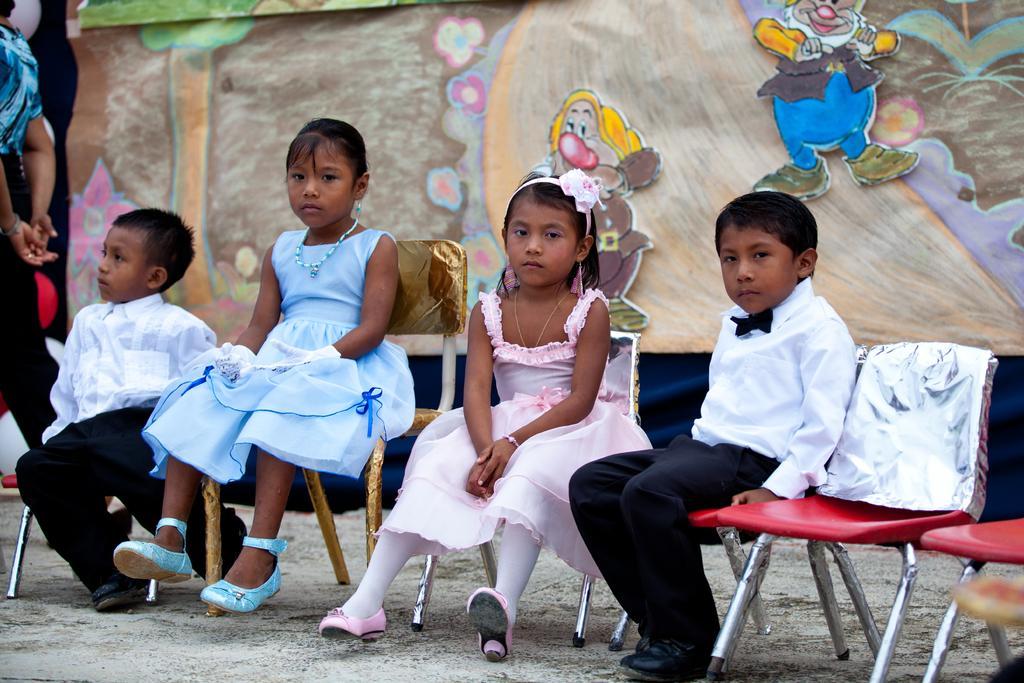In one or two sentences, can you explain what this image depicts? In this image there are four people sitting on the chair. At the back there is a painting of a tree. 